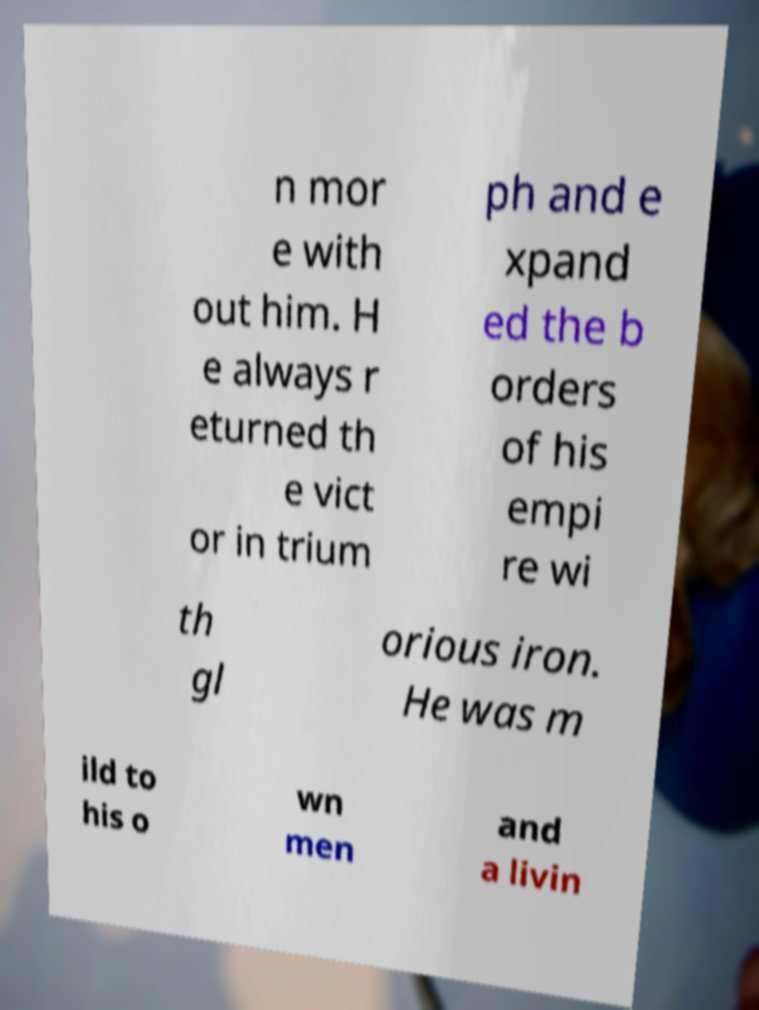For documentation purposes, I need the text within this image transcribed. Could you provide that? n mor e with out him. H e always r eturned th e vict or in trium ph and e xpand ed the b orders of his empi re wi th gl orious iron. He was m ild to his o wn men and a livin 